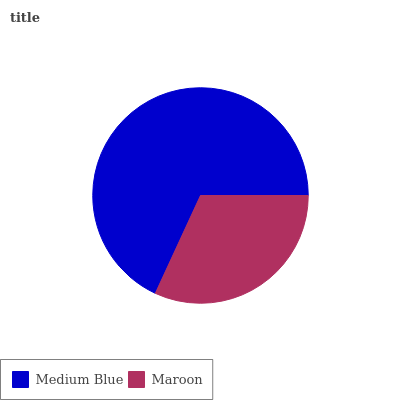Is Maroon the minimum?
Answer yes or no. Yes. Is Medium Blue the maximum?
Answer yes or no. Yes. Is Maroon the maximum?
Answer yes or no. No. Is Medium Blue greater than Maroon?
Answer yes or no. Yes. Is Maroon less than Medium Blue?
Answer yes or no. Yes. Is Maroon greater than Medium Blue?
Answer yes or no. No. Is Medium Blue less than Maroon?
Answer yes or no. No. Is Medium Blue the high median?
Answer yes or no. Yes. Is Maroon the low median?
Answer yes or no. Yes. Is Maroon the high median?
Answer yes or no. No. Is Medium Blue the low median?
Answer yes or no. No. 